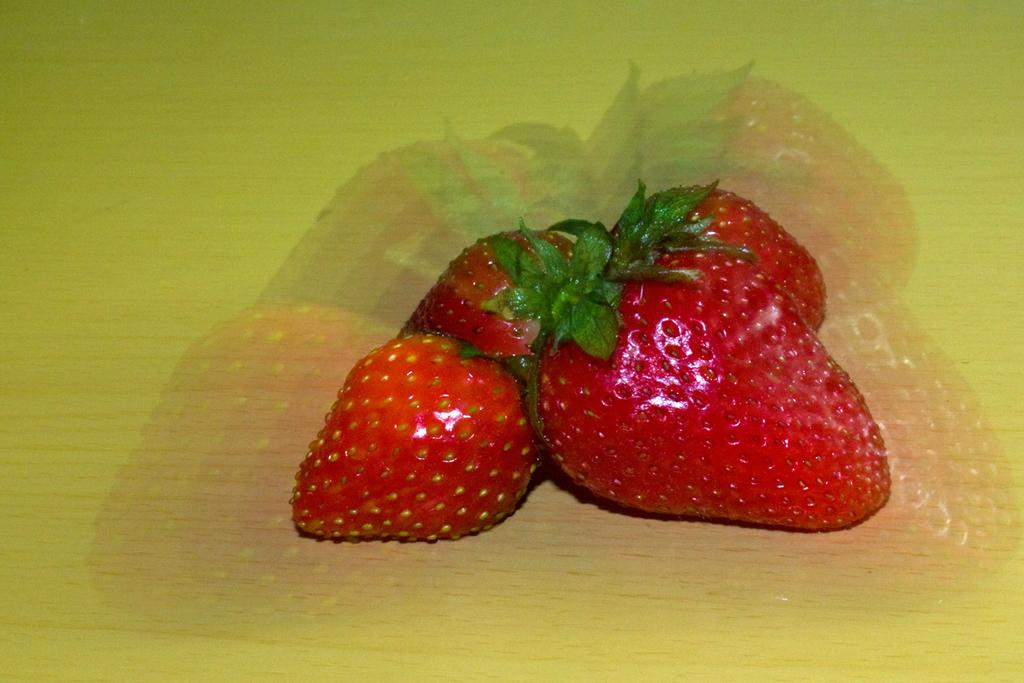What type of fruit is present in the image? There are strawberries in the image. On what surface are the strawberries placed? The strawberries are on a wooden surface. What is the reason behind the strawberries' decision to grow on the wooden surface? The strawberries do not have the ability to make decisions, as they are inanimate objects. The wooden surface is likely a serving board or cutting board, and the strawberries are placed there for presentation or consumption. 